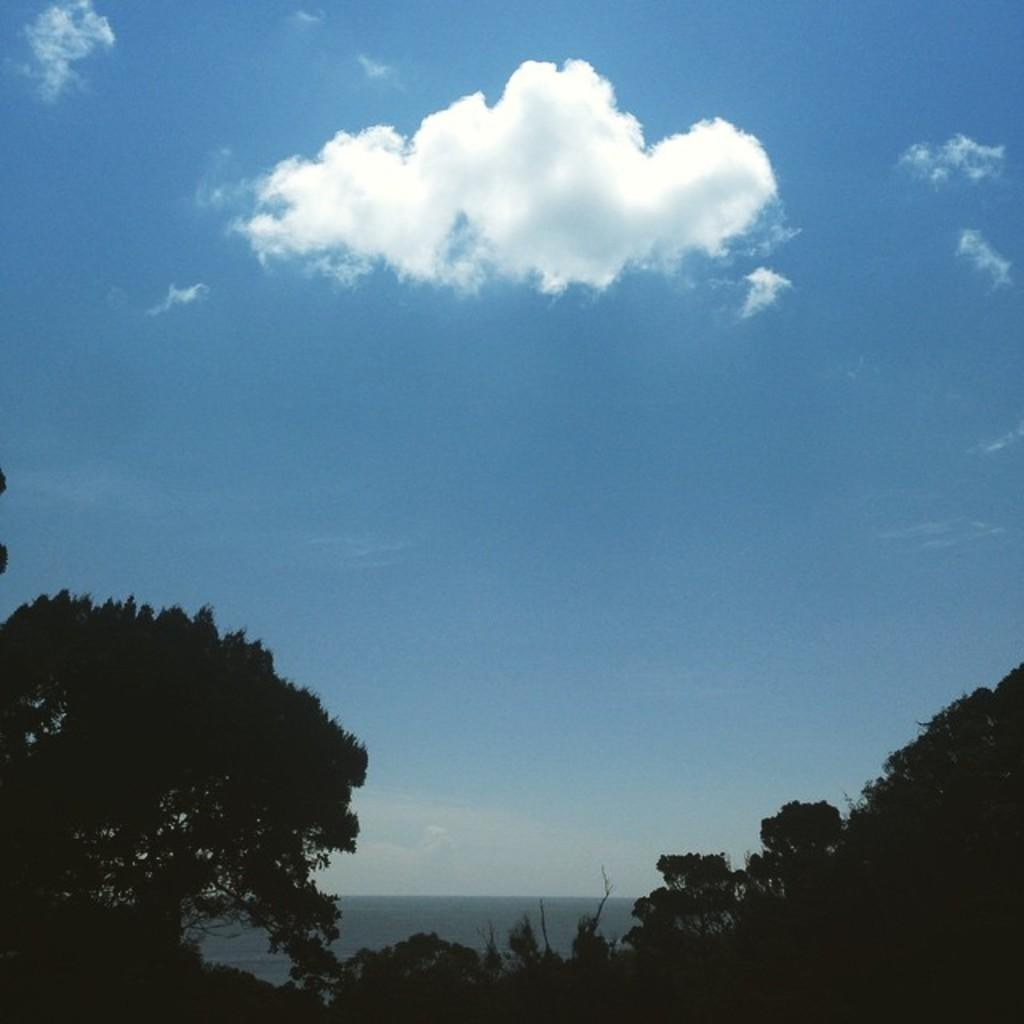What type of vegetation can be seen on the left side of the image? There are trees on the left side of the image. What type of vegetation can be seen on the right side of the image? There are trees on the right side of the image. What natural feature is visible in the background of the image? There is an ocean visible in the background of the image. What is visible in the sky in the image? The sky is visible in the image, and clouds are present. Where is the stove located in the image? There is no stove present in the image. What type of bushes can be seen growing near the trees on the right side of the image? There is no mention of bushes in the image; only trees are mentioned on both the left and right sides. 